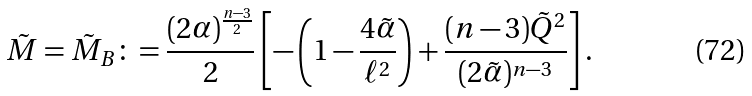Convert formula to latex. <formula><loc_0><loc_0><loc_500><loc_500>\tilde { M } = \tilde { M } _ { B } \colon = \frac { ( 2 \alpha ) ^ { \frac { n - 3 } { 2 } } } { 2 } \left [ - \left ( 1 - \frac { 4 \tilde { \alpha } } { \ell ^ { 2 } } \right ) + \frac { ( n - 3 ) \tilde { Q } ^ { 2 } } { ( 2 \tilde { \alpha } ) ^ { n - 3 } } \right ] .</formula> 